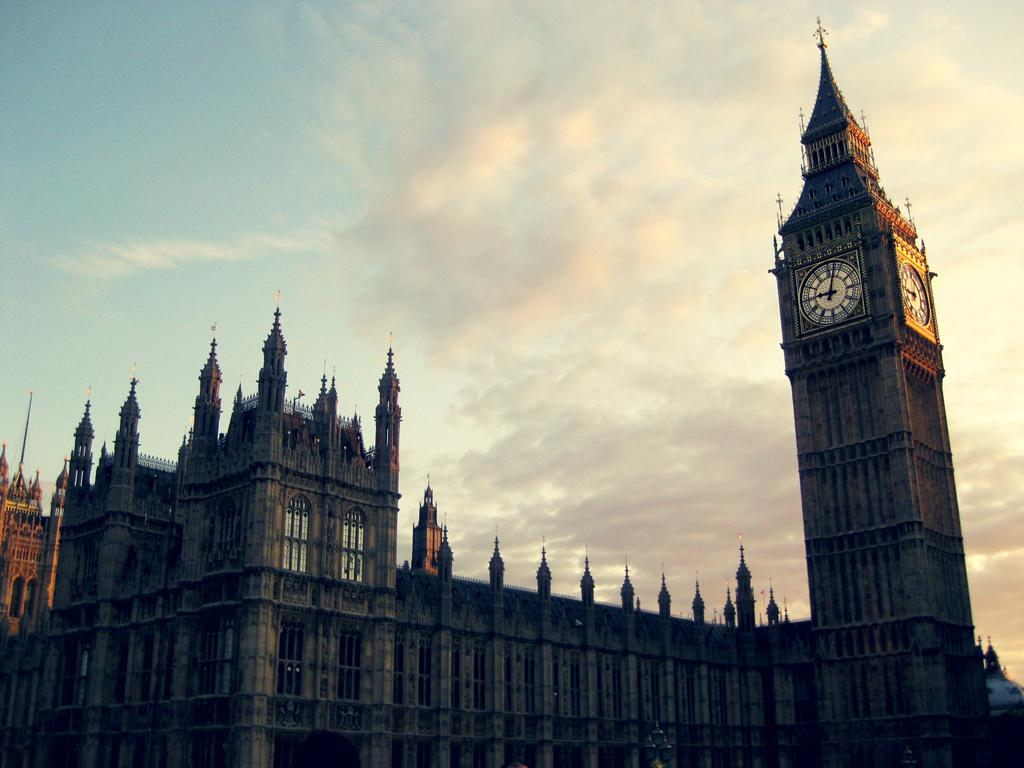What is the main structure in the image? There is a clock tower in the image. What else can be seen in the background of the image? There are buildings in the background of the image. What colors are visible in the sky in the image? The sky is blue and white in color. What type of humor can be seen in the image? There is no humor present in the image; it features a clock tower and buildings in the background. What type of arch is visible in the image? There is no arch present in the image. 